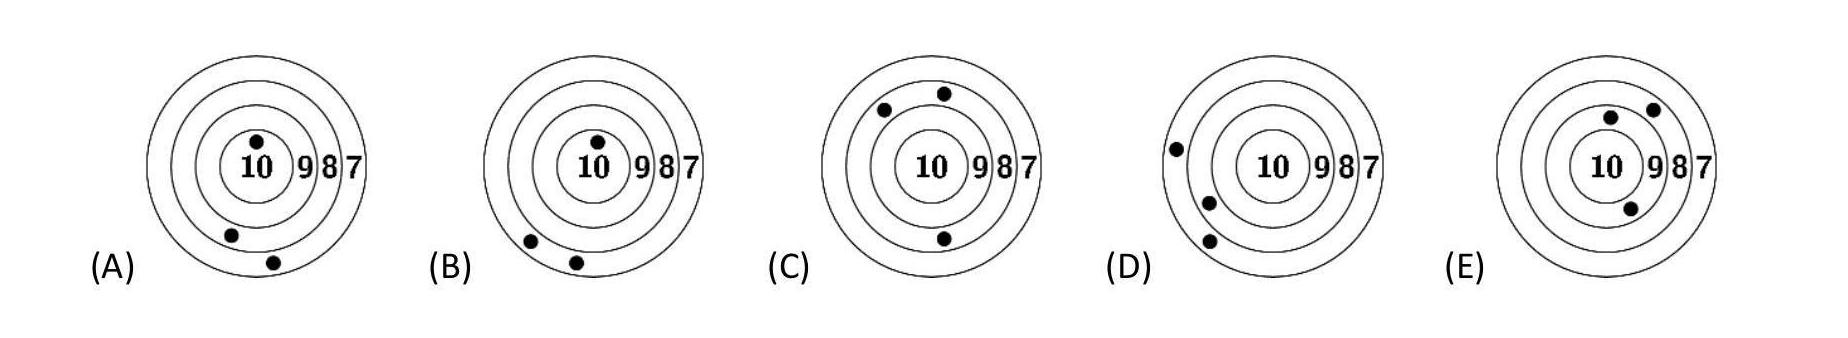Describe what might happen in a subsequent training session to help improve the shooters' performances. In a follow-up training, focusing on steady hand placement, breathing techniques, and regular practice routines could help shooters improve. Target 'A's shooter might benefit from more focused drills on aiming near the bullseye. What type of feedback would be helpful for the shooter of target D? Feedback for the shooter of target 'D' should include tips on refining aim and reducing shot dispersion to increase the accuracy, as the grouping is good but slightly off-center. 